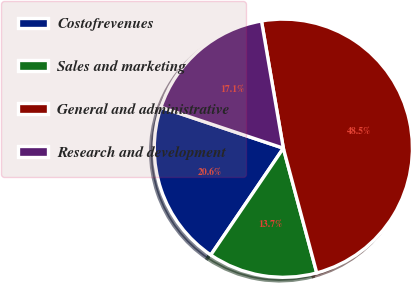Convert chart to OTSL. <chart><loc_0><loc_0><loc_500><loc_500><pie_chart><fcel>Costofrevenues<fcel>Sales and marketing<fcel>General and administrative<fcel>Research and development<nl><fcel>20.64%<fcel>13.67%<fcel>48.54%<fcel>17.15%<nl></chart> 